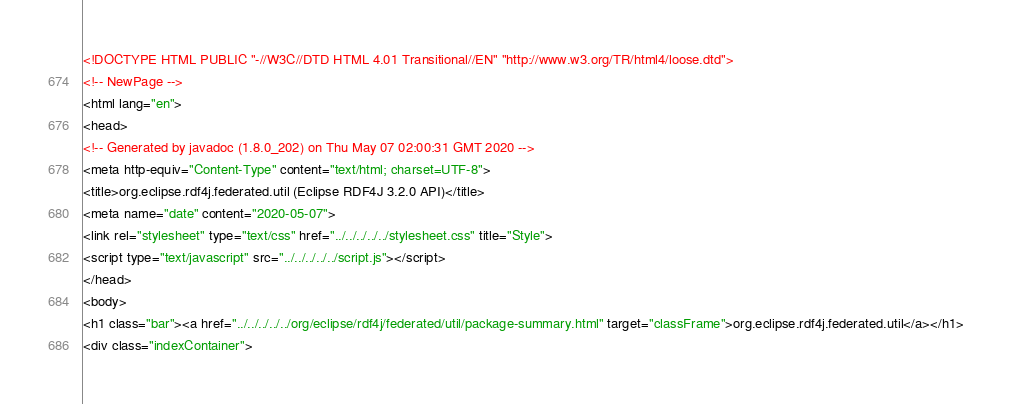Convert code to text. <code><loc_0><loc_0><loc_500><loc_500><_HTML_><!DOCTYPE HTML PUBLIC "-//W3C//DTD HTML 4.01 Transitional//EN" "http://www.w3.org/TR/html4/loose.dtd">
<!-- NewPage -->
<html lang="en">
<head>
<!-- Generated by javadoc (1.8.0_202) on Thu May 07 02:00:31 GMT 2020 -->
<meta http-equiv="Content-Type" content="text/html; charset=UTF-8">
<title>org.eclipse.rdf4j.federated.util (Eclipse RDF4J 3.2.0 API)</title>
<meta name="date" content="2020-05-07">
<link rel="stylesheet" type="text/css" href="../../../../../stylesheet.css" title="Style">
<script type="text/javascript" src="../../../../../script.js"></script>
</head>
<body>
<h1 class="bar"><a href="../../../../../org/eclipse/rdf4j/federated/util/package-summary.html" target="classFrame">org.eclipse.rdf4j.federated.util</a></h1>
<div class="indexContainer"></code> 